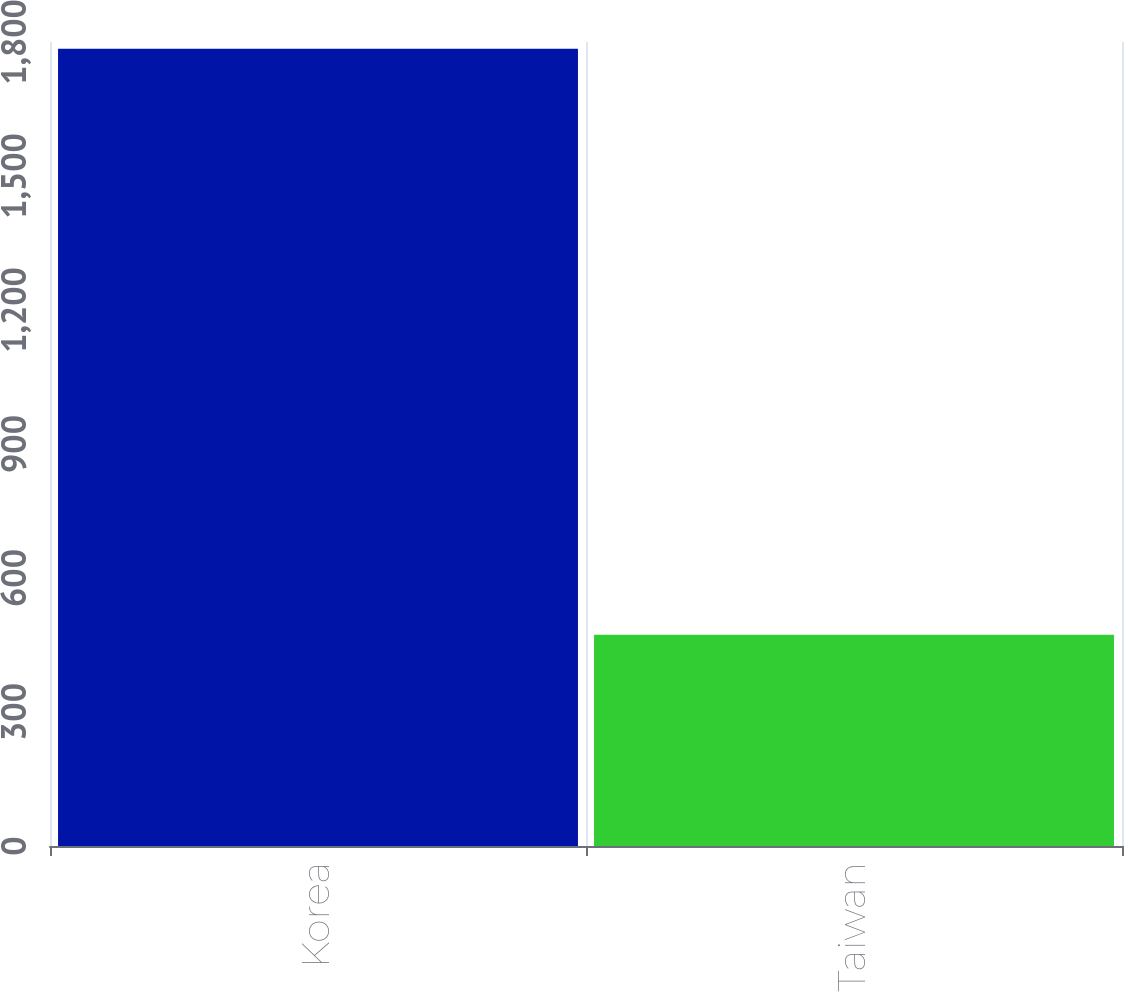<chart> <loc_0><loc_0><loc_500><loc_500><bar_chart><fcel>Korea<fcel>Taiwan<nl><fcel>1785<fcel>473<nl></chart> 